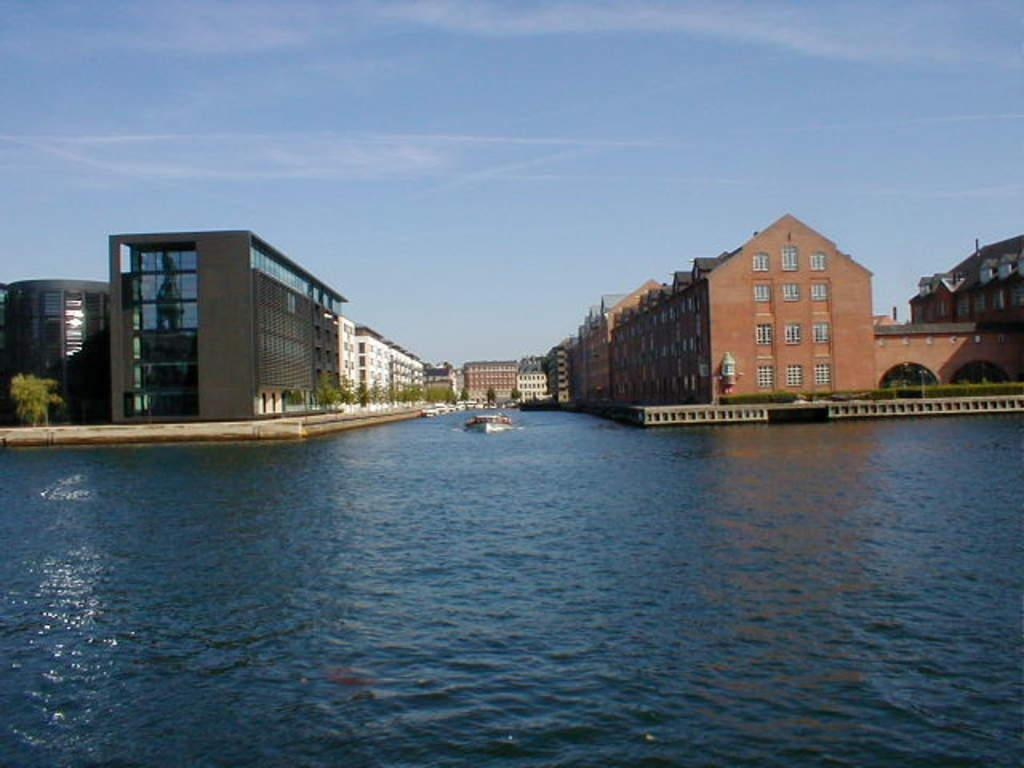What is visible in the image? Water is visible in the image. What can be seen in the background of the image? There are buildings with windows in the background, and trees are present beside the buildings. What is the color of the sky in the image? The sky is blue in color. What type of tools does the carpenter use in the image? There is no carpenter present in the image, so it is not possible to determine what tools they might use. What is the voice of the person speaking in the image? There is no person speaking in the image, so it is not possible to determine the voice. 